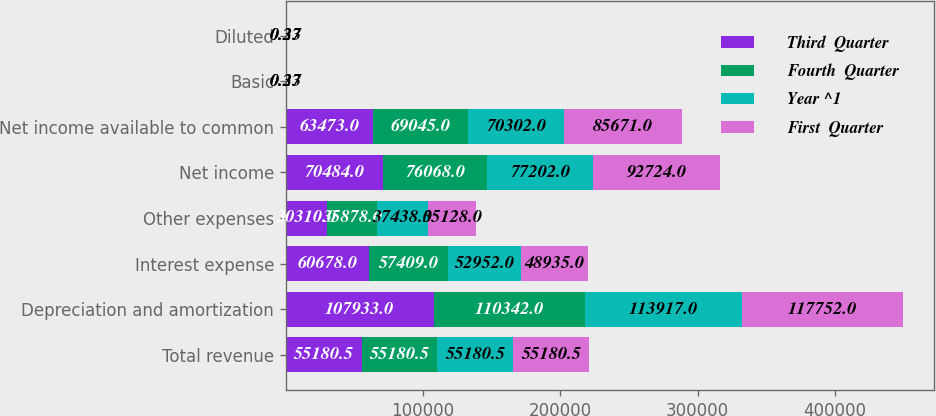Convert chart to OTSL. <chart><loc_0><loc_0><loc_500><loc_500><stacked_bar_chart><ecel><fcel>Total revenue<fcel>Depreciation and amortization<fcel>Interest expense<fcel>Other expenses<fcel>Net income<fcel>Net income available to common<fcel>Basic<fcel>Diluted<nl><fcel>Third  Quarter<fcel>55180.5<fcel>107933<fcel>60678<fcel>30310<fcel>70484<fcel>63473<fcel>0.25<fcel>0.25<nl><fcel>Fourth  Quarter<fcel>55180.5<fcel>110342<fcel>57409<fcel>35878<fcel>76068<fcel>69045<fcel>0.27<fcel>0.27<nl><fcel>Year ^1<fcel>55180.5<fcel>113917<fcel>52952<fcel>37438<fcel>77202<fcel>70302<fcel>0.27<fcel>0.27<nl><fcel>First  Quarter<fcel>55180.5<fcel>117752<fcel>48935<fcel>35128<fcel>92724<fcel>85671<fcel>0.33<fcel>0.33<nl></chart> 